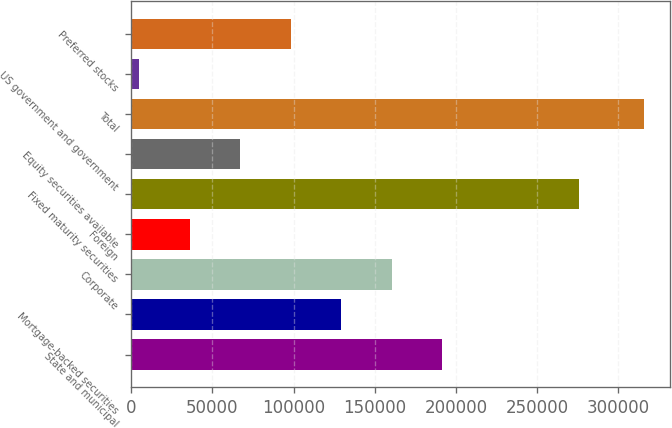Convert chart. <chart><loc_0><loc_0><loc_500><loc_500><bar_chart><fcel>State and municipal<fcel>Mortgage-backed securities<fcel>Corporate<fcel>Foreign<fcel>Fixed maturity securities<fcel>Equity securities available<fcel>Total<fcel>US government and government<fcel>Preferred stocks<nl><fcel>191411<fcel>129207<fcel>160309<fcel>35901.8<fcel>276006<fcel>67003.6<fcel>315818<fcel>4800<fcel>98105.4<nl></chart> 